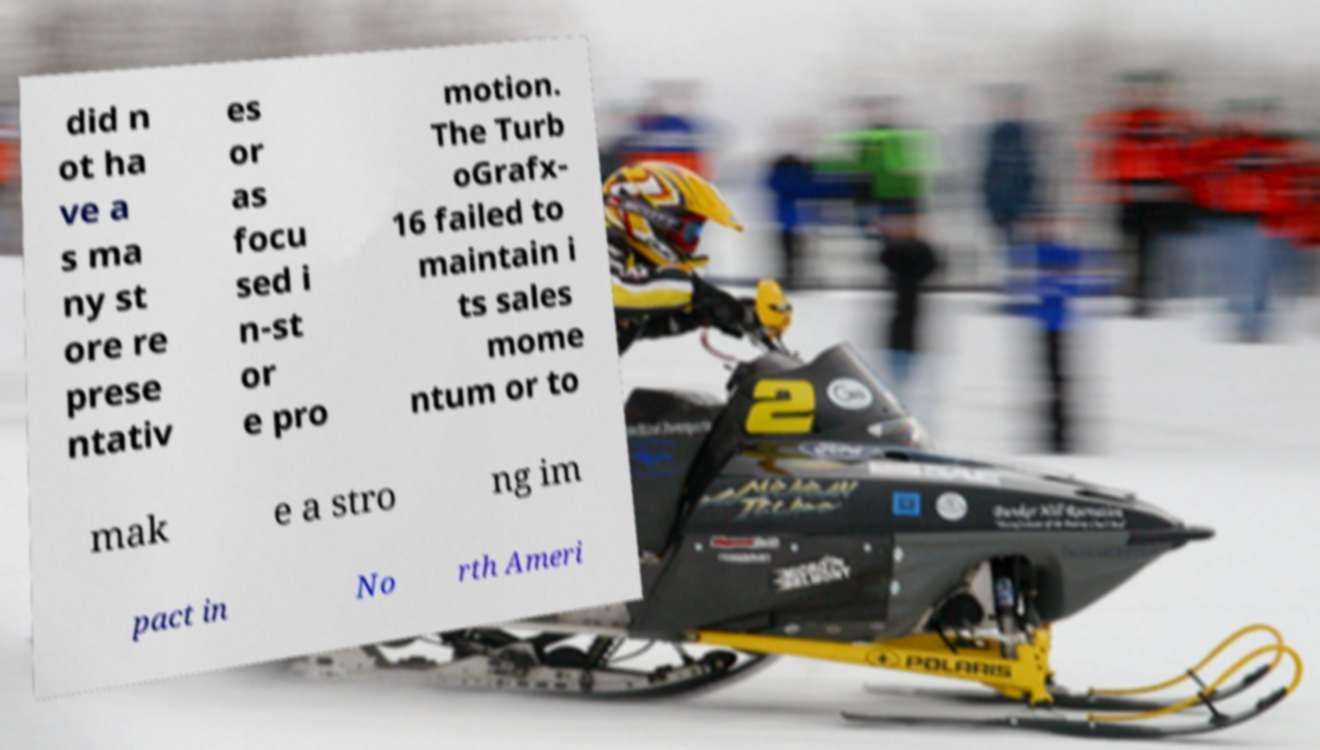I need the written content from this picture converted into text. Can you do that? did n ot ha ve a s ma ny st ore re prese ntativ es or as focu sed i n-st or e pro motion. The Turb oGrafx- 16 failed to maintain i ts sales mome ntum or to mak e a stro ng im pact in No rth Ameri 